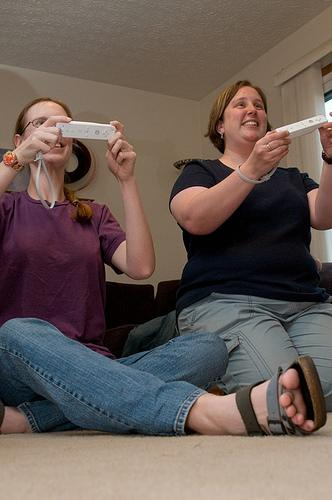What are these women looking at? Please explain your reasoning. monitor screen. They are playing a video game. 